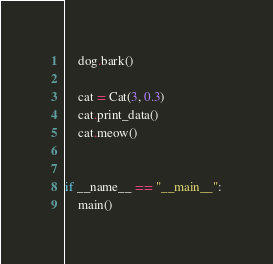Convert code to text. <code><loc_0><loc_0><loc_500><loc_500><_Python_>    dog.bark()

    cat = Cat(3, 0.3)
    cat.print_data()
    cat.meow()


if __name__ == "__main__":
    main()
</code> 